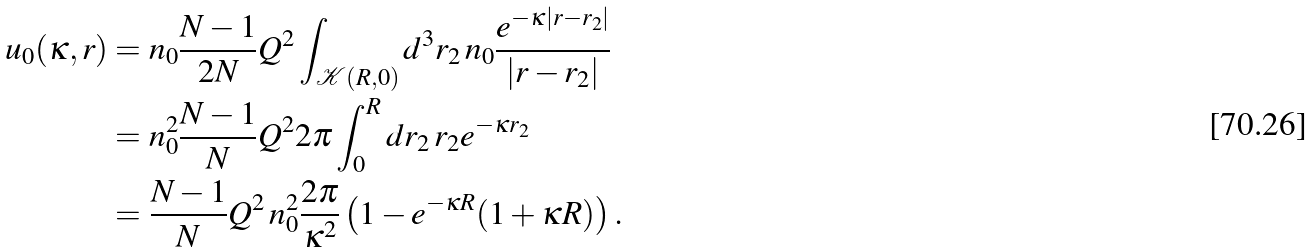<formula> <loc_0><loc_0><loc_500><loc_500>u _ { 0 } ( \kappa , r ) & = n _ { 0 } \frac { N - 1 } { 2 N } Q ^ { 2 } \int _ { \mathcal { K } ( R , 0 ) } d ^ { 3 } r _ { 2 } \, n _ { 0 } \frac { e ^ { - \kappa | { r } - { r } _ { 2 } | } } { | { r } - { r } _ { 2 } | } \\ & = n _ { 0 } ^ { 2 } \frac { N - 1 } { N } Q ^ { 2 } 2 \pi \int _ { 0 } ^ { R } d r _ { 2 } \, r _ { 2 } e ^ { - \kappa r _ { 2 } } \\ & = \frac { N - 1 } { N } Q ^ { 2 } \, n _ { 0 } ^ { 2 } \frac { 2 \pi } { \kappa ^ { 2 } } \left ( 1 - e ^ { - \kappa R } ( 1 + \kappa R ) \right ) .</formula> 